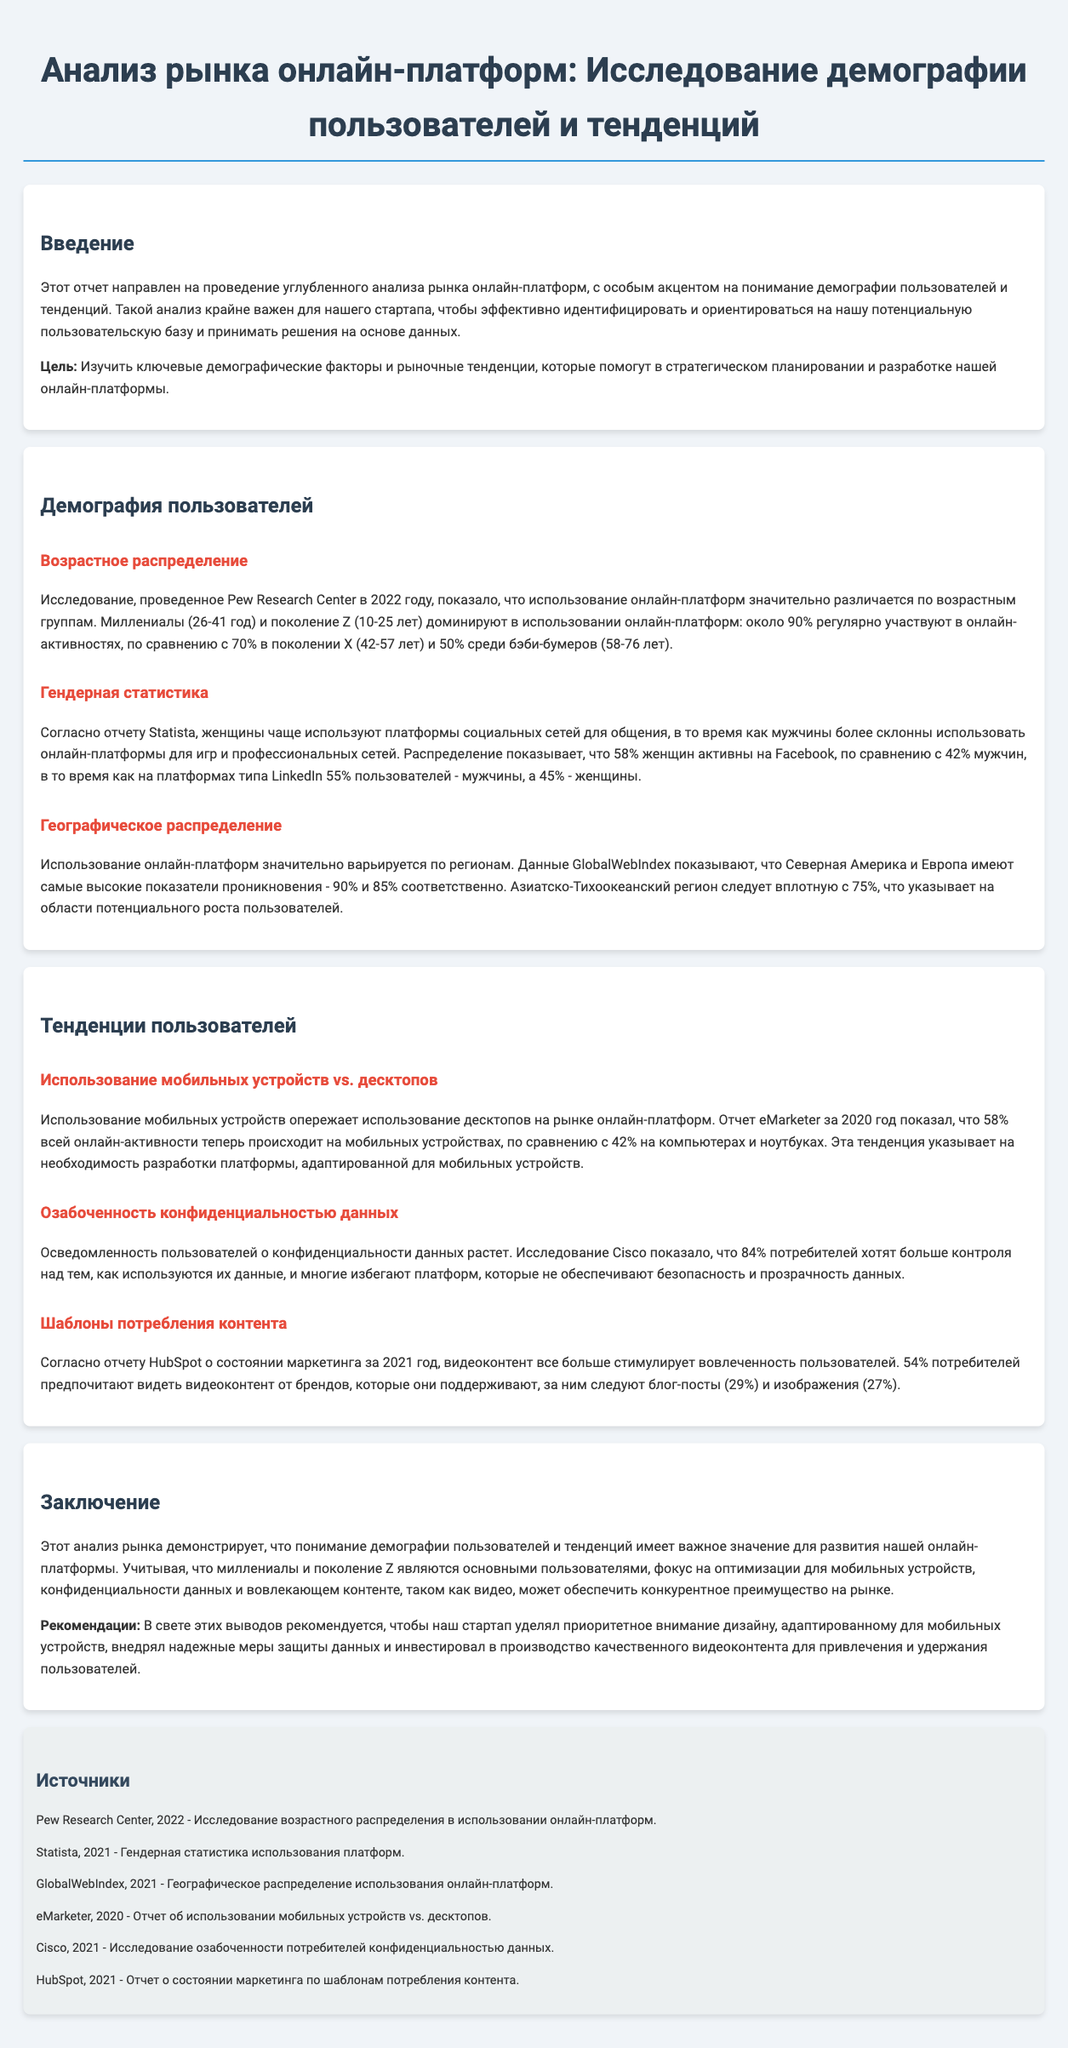что является основной целью анализа? Основной целью анализа является изучение ключевых демографических факторов и рыночных тенденций, которые помогут в стратегическом планировании и разработке платформы.
Answer: Изучить ключевые демографические факторы и рыночные тенденции какая возрастная группа доминирует в использовании онлайн-платформ? Миллениалы и поколение Z доминируют в использовании онлайн-платформ, с примерно 90% участия в онлайн-активностях.
Answer: Миллениалы и поколение Z какое процентное соотношение женщин и мужчин активно использует Facebook? На Facebook активно 58% женщин и 42% мужчин.
Answer: 58% женщин, 42% мужчин каково использование мобильных устройств по сравнению с десктопами? Использование мобильных устройств составляет 58%, в то время как использование десктопов - 42%.
Answer: 58% на мобильных устройствах какому проценту потребителей важно иметь больше контроля над использованием их данных? 84% потребителей хотят больше контроля над тем, как используются их данные.
Answer: 84% что демонстрирует рост интереса к контенту в виде видео? 54% потребителей предпочитают видеть видеоконтент от брендов, что свидетельствует о его растущем интересе.
Answer: 54% в каких регионах самое высокое использование онлайн-платформ? Самые высокие показатели проникновения онлайн-платформ в Северной Америке и Европе, 90% и 85% соответственно.
Answer: Северная Америка и Европа какие рекомендации даны для стартапа в заключении? Рекомендации включают приоритетное внимание дизайну для мобильных устройств, защиту данных и производство видеоконтента.
Answer: Дизайн для мобильных устройств, защита данных, видеоконтент 